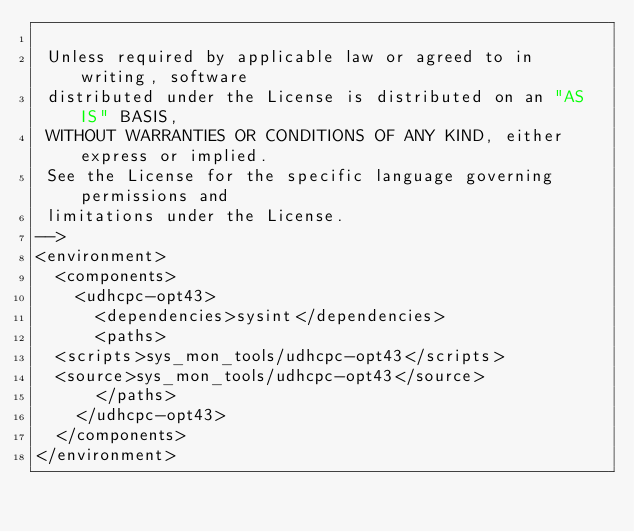Convert code to text. <code><loc_0><loc_0><loc_500><loc_500><_XML_>
 Unless required by applicable law or agreed to in writing, software
 distributed under the License is distributed on an "AS IS" BASIS,
 WITHOUT WARRANTIES OR CONDITIONS OF ANY KIND, either express or implied.
 See the License for the specific language governing permissions and
 limitations under the License.
-->
<environment>
  <components>
    <udhcpc-opt43>
      <dependencies>sysint</dependencies>
      <paths>
	<scripts>sys_mon_tools/udhcpc-opt43</scripts>
	<source>sys_mon_tools/udhcpc-opt43</source>
      </paths>
    </udhcpc-opt43>
  </components>
</environment>

</code> 